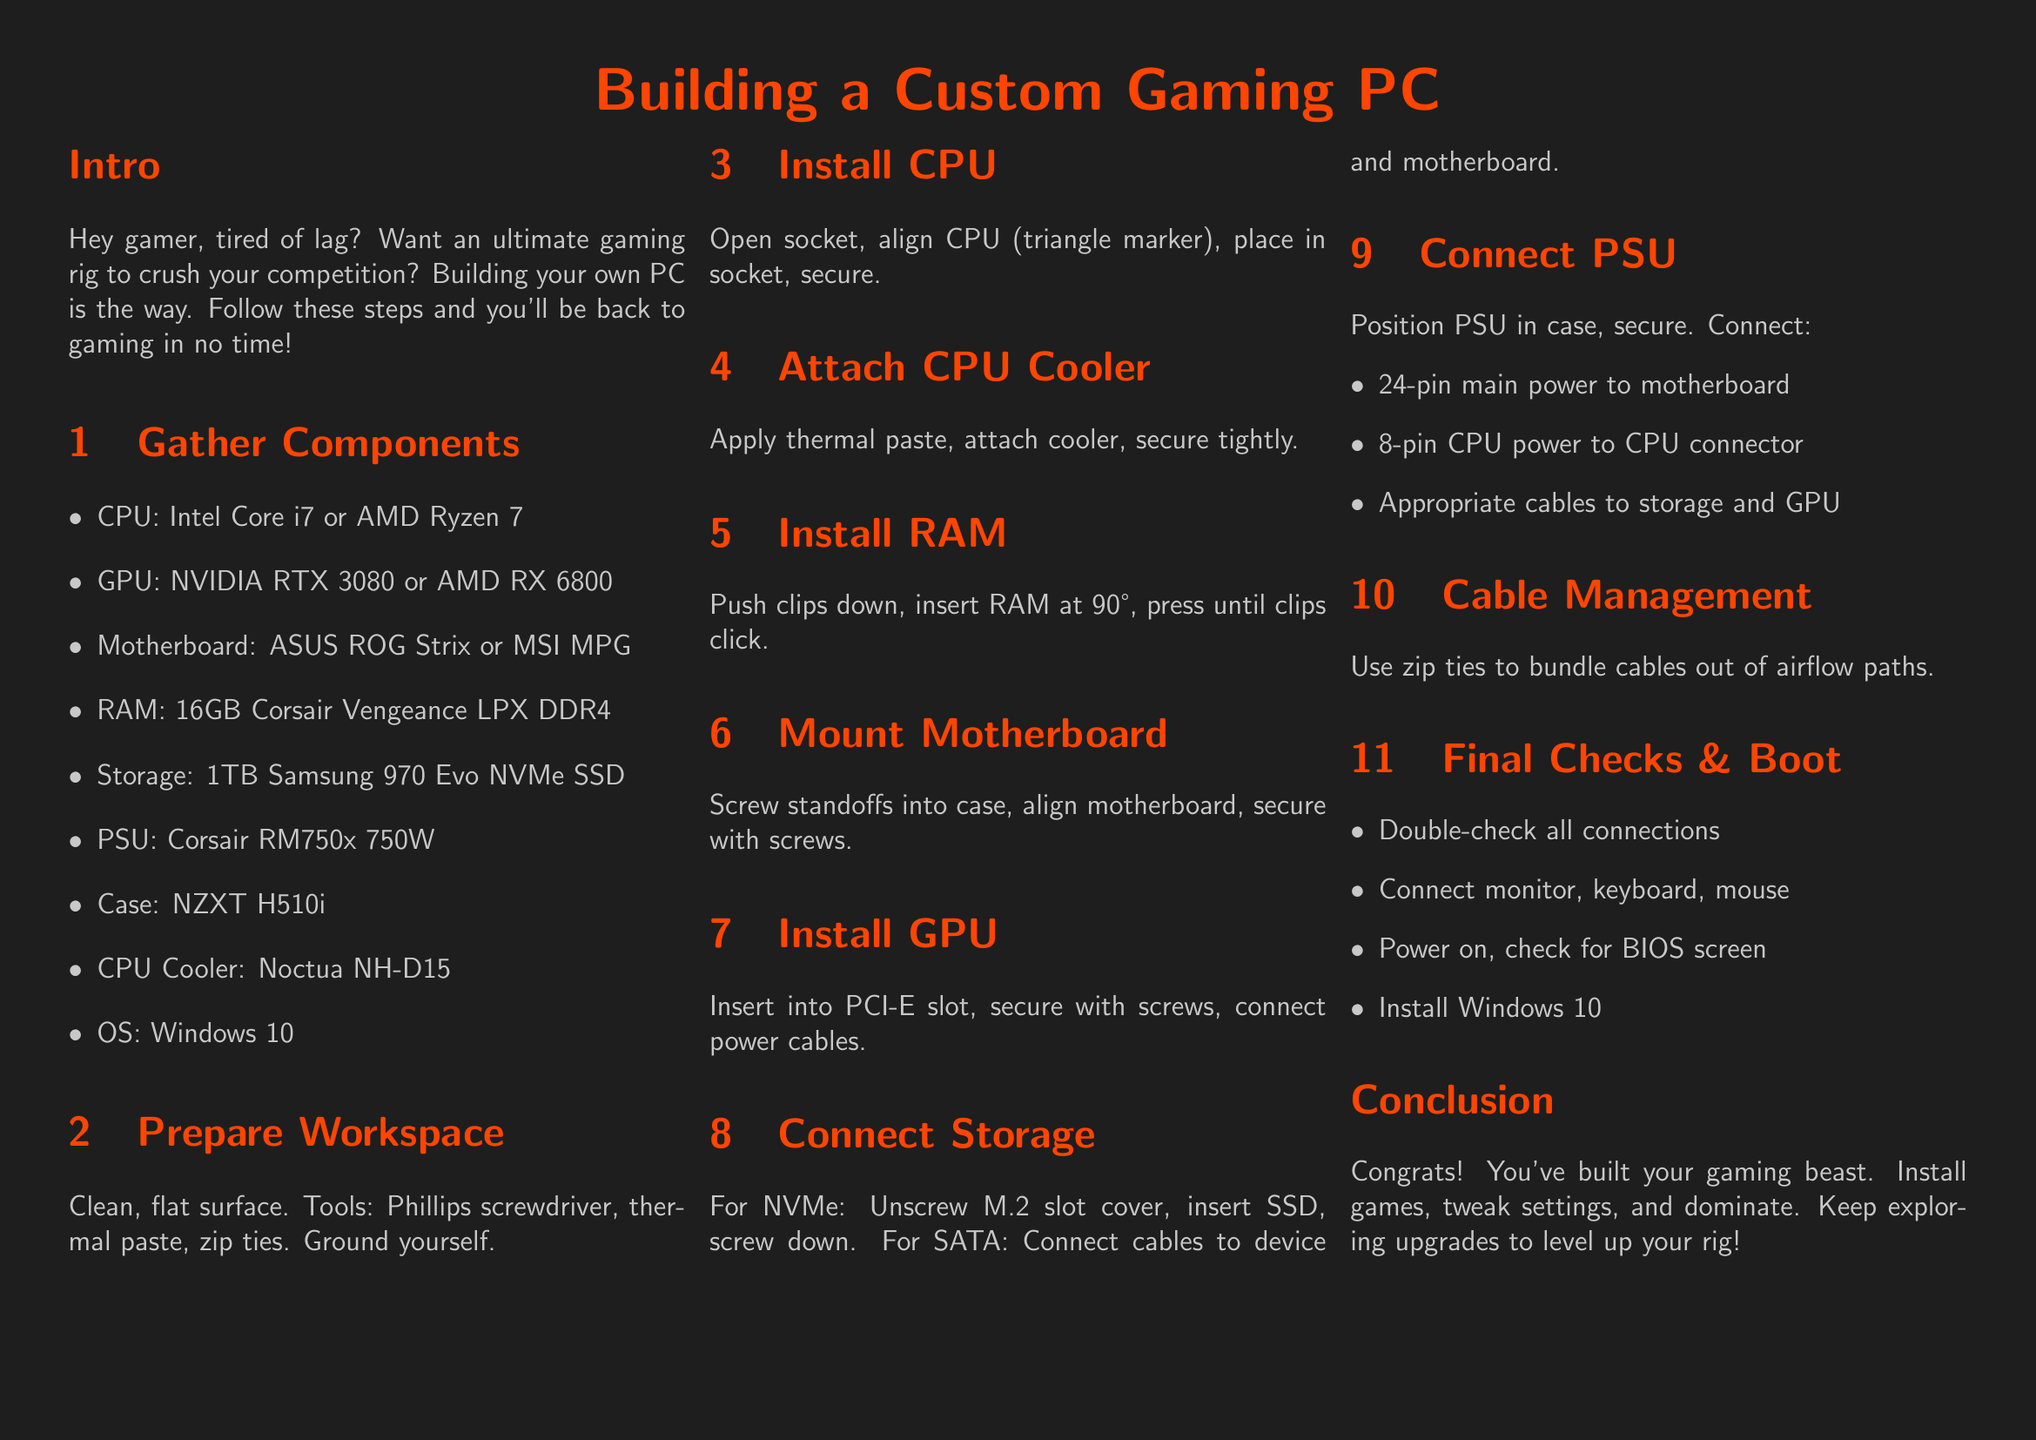What CPU is recommended? The document lists Intel Core i7 or AMD Ryzen 7 as the recommended CPUs for building a custom gaming PC.
Answer: Intel Core i7 or AMD Ryzen 7 What is the recommended GPU? The recommended graphics cards mentioned are NVIDIA RTX 3080 or AMD RX 6800.
Answer: NVIDIA RTX 3080 or AMD RX 6800 How much RAM is suggested? According to the document, 16GB Corsair Vengeance LPX DDR4 is suggested for the build.
Answer: 16GB Corsair Vengeance LPX DDR4 What tool is needed to secure components? The document specifies needing a Phillips screwdriver as a tool for assembly.
Answer: Phillips screwdriver What is the first step in the assembly process? The first step involves gathering all the necessary components before starting the assembly.
Answer: Gather Components What is the purpose of thermal paste? Thermal paste is applied to improve heat transfer between the CPU and the cooler during assembly.
Answer: Improve heat transfer How do you ensure cables are organized? The document recommends using zip ties to bundle cables and avoid airflow obstruction.
Answer: Zip ties What do you need to connect to monitor and keyboard? It specifies connecting monitor, keyboard, and mouse to boot the system for the first time.
Answer: Monitor, keyboard, mouse What is the last step in the assembly guide? The final step involves installing Windows 10 after checking all connections and powering on the PC.
Answer: Install Windows 10 